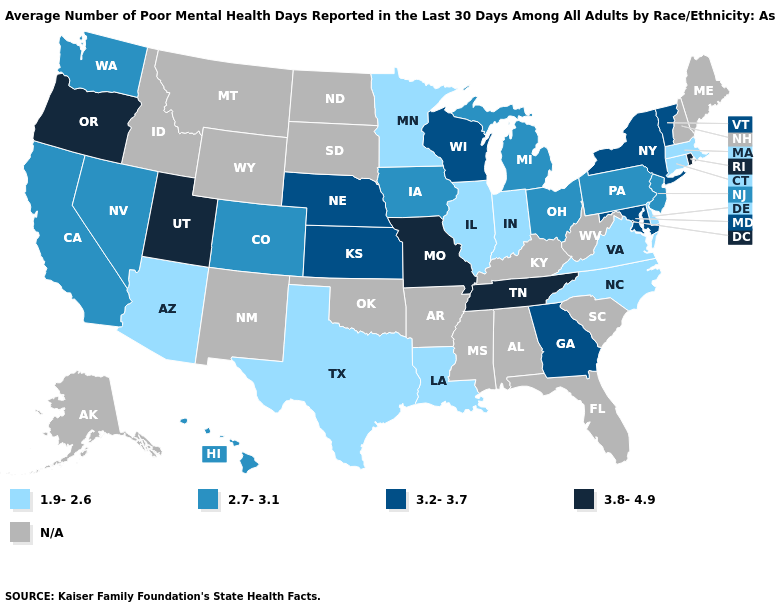Name the states that have a value in the range N/A?
Answer briefly. Alabama, Alaska, Arkansas, Florida, Idaho, Kentucky, Maine, Mississippi, Montana, New Hampshire, New Mexico, North Dakota, Oklahoma, South Carolina, South Dakota, West Virginia, Wyoming. What is the lowest value in states that border Connecticut?
Answer briefly. 1.9-2.6. What is the value of South Dakota?
Answer briefly. N/A. Among the states that border Washington , which have the lowest value?
Keep it brief. Oregon. Name the states that have a value in the range 1.9-2.6?
Give a very brief answer. Arizona, Connecticut, Delaware, Illinois, Indiana, Louisiana, Massachusetts, Minnesota, North Carolina, Texas, Virginia. What is the highest value in states that border Arkansas?
Concise answer only. 3.8-4.9. Does California have the lowest value in the USA?
Give a very brief answer. No. Does the first symbol in the legend represent the smallest category?
Short answer required. Yes. Does the map have missing data?
Short answer required. Yes. What is the highest value in the USA?
Give a very brief answer. 3.8-4.9. Does the first symbol in the legend represent the smallest category?
Concise answer only. Yes. Does Rhode Island have the highest value in the Northeast?
Concise answer only. Yes. What is the lowest value in the USA?
Short answer required. 1.9-2.6. What is the value of Michigan?
Write a very short answer. 2.7-3.1. 